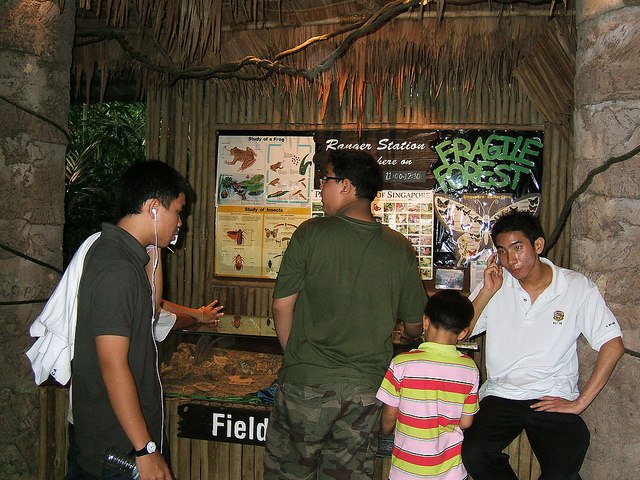Please transcribe the text in this image. Ramer Station SINGAPORE FRAGILE FOREST Field 11:00 here 